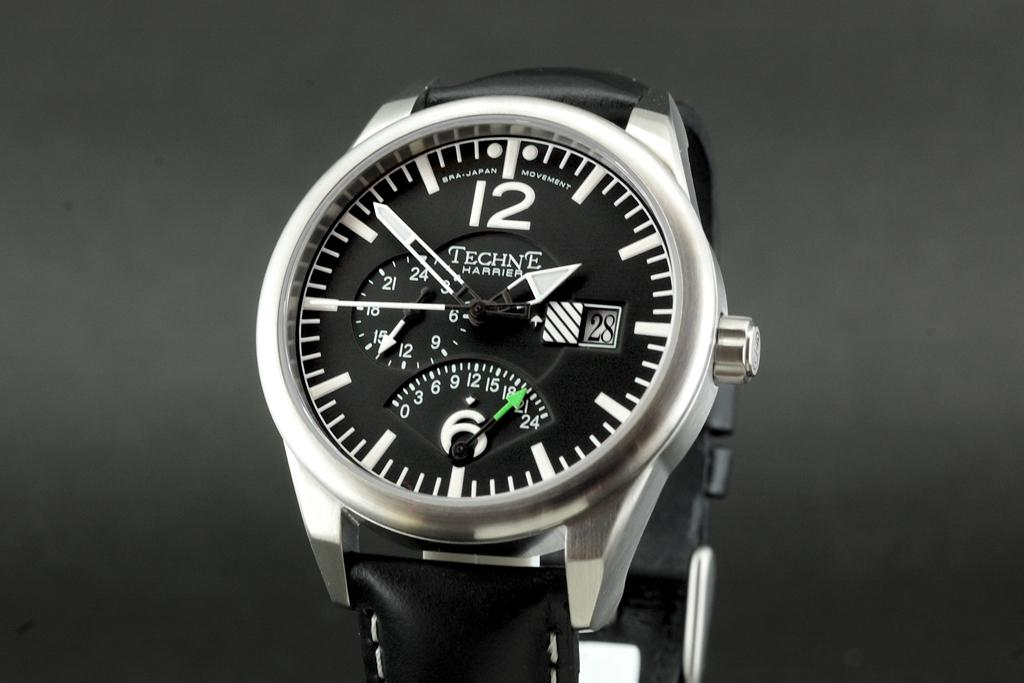<image>
Relay a brief, clear account of the picture shown. A silver and black Techne Harrier watch made in Japan. 